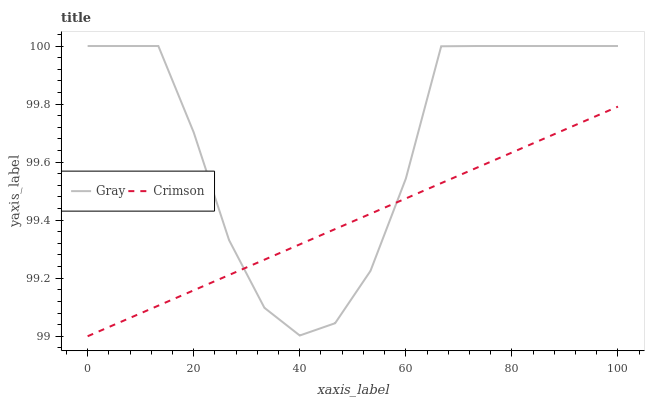Does Crimson have the minimum area under the curve?
Answer yes or no. Yes. Does Gray have the maximum area under the curve?
Answer yes or no. Yes. Does Gray have the minimum area under the curve?
Answer yes or no. No. Is Crimson the smoothest?
Answer yes or no. Yes. Is Gray the roughest?
Answer yes or no. Yes. Is Gray the smoothest?
Answer yes or no. No. Does Gray have the lowest value?
Answer yes or no. No. Does Gray have the highest value?
Answer yes or no. Yes. Does Gray intersect Crimson?
Answer yes or no. Yes. Is Gray less than Crimson?
Answer yes or no. No. Is Gray greater than Crimson?
Answer yes or no. No. 